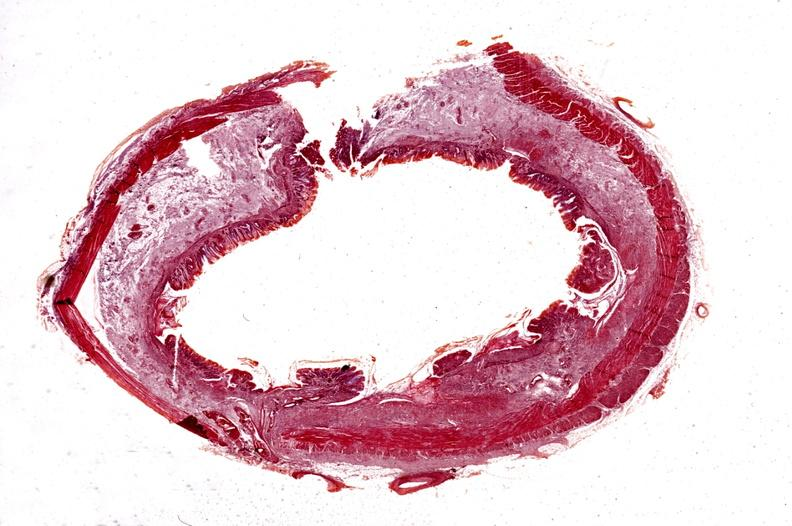what is present?
Answer the question using a single word or phrase. Gastrointestinal 